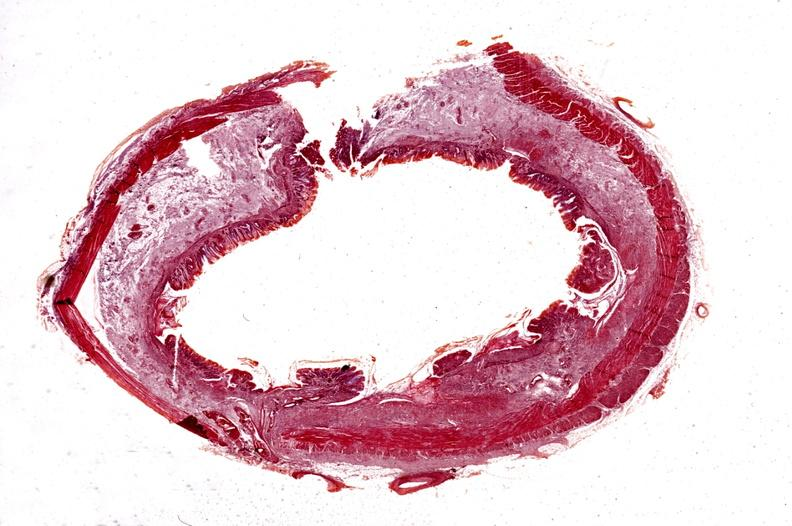what is present?
Answer the question using a single word or phrase. Gastrointestinal 